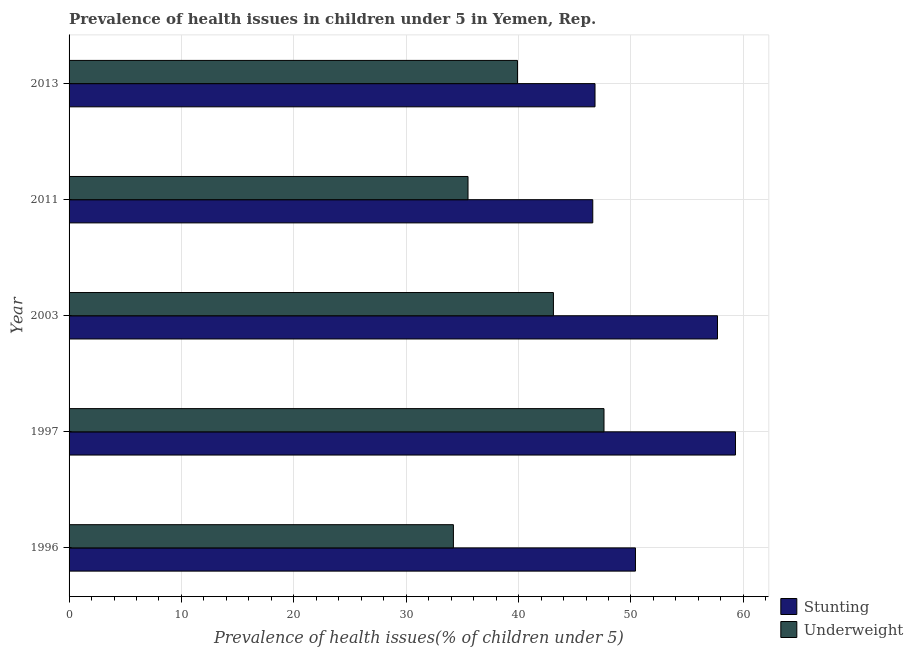How many different coloured bars are there?
Make the answer very short. 2. Are the number of bars per tick equal to the number of legend labels?
Your response must be concise. Yes. How many bars are there on the 3rd tick from the top?
Provide a succinct answer. 2. What is the label of the 2nd group of bars from the top?
Give a very brief answer. 2011. In how many cases, is the number of bars for a given year not equal to the number of legend labels?
Provide a succinct answer. 0. What is the percentage of stunted children in 2013?
Ensure brevity in your answer.  46.8. Across all years, what is the maximum percentage of stunted children?
Your response must be concise. 59.3. Across all years, what is the minimum percentage of stunted children?
Make the answer very short. 46.6. In which year was the percentage of underweight children maximum?
Provide a succinct answer. 1997. What is the total percentage of underweight children in the graph?
Offer a terse response. 200.3. What is the difference between the percentage of underweight children in 2003 and the percentage of stunted children in 1997?
Ensure brevity in your answer.  -16.2. What is the average percentage of underweight children per year?
Offer a terse response. 40.06. What is the ratio of the percentage of underweight children in 1996 to that in 2003?
Ensure brevity in your answer.  0.79. Is the percentage of underweight children in 2011 less than that in 2013?
Make the answer very short. Yes. Is the difference between the percentage of stunted children in 1997 and 2011 greater than the difference between the percentage of underweight children in 1997 and 2011?
Offer a very short reply. Yes. What is the difference between the highest and the second highest percentage of stunted children?
Your answer should be compact. 1.6. What does the 1st bar from the top in 2011 represents?
Offer a very short reply. Underweight. What does the 1st bar from the bottom in 1997 represents?
Provide a succinct answer. Stunting. Are all the bars in the graph horizontal?
Your answer should be compact. Yes. How many years are there in the graph?
Your answer should be very brief. 5. What is the difference between two consecutive major ticks on the X-axis?
Offer a terse response. 10. Does the graph contain grids?
Make the answer very short. Yes. Where does the legend appear in the graph?
Provide a short and direct response. Bottom right. How many legend labels are there?
Make the answer very short. 2. What is the title of the graph?
Your response must be concise. Prevalence of health issues in children under 5 in Yemen, Rep. What is the label or title of the X-axis?
Provide a succinct answer. Prevalence of health issues(% of children under 5). What is the Prevalence of health issues(% of children under 5) of Stunting in 1996?
Ensure brevity in your answer.  50.4. What is the Prevalence of health issues(% of children under 5) in Underweight in 1996?
Ensure brevity in your answer.  34.2. What is the Prevalence of health issues(% of children under 5) of Stunting in 1997?
Offer a very short reply. 59.3. What is the Prevalence of health issues(% of children under 5) in Underweight in 1997?
Ensure brevity in your answer.  47.6. What is the Prevalence of health issues(% of children under 5) of Stunting in 2003?
Make the answer very short. 57.7. What is the Prevalence of health issues(% of children under 5) in Underweight in 2003?
Your answer should be compact. 43.1. What is the Prevalence of health issues(% of children under 5) in Stunting in 2011?
Ensure brevity in your answer.  46.6. What is the Prevalence of health issues(% of children under 5) of Underweight in 2011?
Provide a succinct answer. 35.5. What is the Prevalence of health issues(% of children under 5) of Stunting in 2013?
Provide a succinct answer. 46.8. What is the Prevalence of health issues(% of children under 5) in Underweight in 2013?
Provide a succinct answer. 39.9. Across all years, what is the maximum Prevalence of health issues(% of children under 5) of Stunting?
Keep it short and to the point. 59.3. Across all years, what is the maximum Prevalence of health issues(% of children under 5) in Underweight?
Your answer should be very brief. 47.6. Across all years, what is the minimum Prevalence of health issues(% of children under 5) of Stunting?
Your answer should be very brief. 46.6. Across all years, what is the minimum Prevalence of health issues(% of children under 5) of Underweight?
Provide a succinct answer. 34.2. What is the total Prevalence of health issues(% of children under 5) in Stunting in the graph?
Make the answer very short. 260.8. What is the total Prevalence of health issues(% of children under 5) in Underweight in the graph?
Provide a succinct answer. 200.3. What is the difference between the Prevalence of health issues(% of children under 5) in Underweight in 1996 and that in 1997?
Make the answer very short. -13.4. What is the difference between the Prevalence of health issues(% of children under 5) in Stunting in 1996 and that in 2003?
Ensure brevity in your answer.  -7.3. What is the difference between the Prevalence of health issues(% of children under 5) of Stunting in 1996 and that in 2011?
Your answer should be very brief. 3.8. What is the difference between the Prevalence of health issues(% of children under 5) in Underweight in 1996 and that in 2011?
Your answer should be compact. -1.3. What is the difference between the Prevalence of health issues(% of children under 5) in Stunting in 1997 and that in 2013?
Provide a short and direct response. 12.5. What is the difference between the Prevalence of health issues(% of children under 5) of Underweight in 2003 and that in 2011?
Provide a short and direct response. 7.6. What is the difference between the Prevalence of health issues(% of children under 5) in Stunting in 2003 and that in 2013?
Make the answer very short. 10.9. What is the difference between the Prevalence of health issues(% of children under 5) of Underweight in 2011 and that in 2013?
Your response must be concise. -4.4. What is the difference between the Prevalence of health issues(% of children under 5) in Stunting in 1996 and the Prevalence of health issues(% of children under 5) in Underweight in 1997?
Make the answer very short. 2.8. What is the difference between the Prevalence of health issues(% of children under 5) of Stunting in 1996 and the Prevalence of health issues(% of children under 5) of Underweight in 2003?
Provide a succinct answer. 7.3. What is the difference between the Prevalence of health issues(% of children under 5) of Stunting in 1997 and the Prevalence of health issues(% of children under 5) of Underweight in 2003?
Provide a short and direct response. 16.2. What is the difference between the Prevalence of health issues(% of children under 5) in Stunting in 1997 and the Prevalence of health issues(% of children under 5) in Underweight in 2011?
Your answer should be compact. 23.8. What is the difference between the Prevalence of health issues(% of children under 5) of Stunting in 2011 and the Prevalence of health issues(% of children under 5) of Underweight in 2013?
Give a very brief answer. 6.7. What is the average Prevalence of health issues(% of children under 5) of Stunting per year?
Keep it short and to the point. 52.16. What is the average Prevalence of health issues(% of children under 5) in Underweight per year?
Give a very brief answer. 40.06. In the year 1996, what is the difference between the Prevalence of health issues(% of children under 5) of Stunting and Prevalence of health issues(% of children under 5) of Underweight?
Ensure brevity in your answer.  16.2. In the year 1997, what is the difference between the Prevalence of health issues(% of children under 5) of Stunting and Prevalence of health issues(% of children under 5) of Underweight?
Your answer should be compact. 11.7. In the year 2003, what is the difference between the Prevalence of health issues(% of children under 5) in Stunting and Prevalence of health issues(% of children under 5) in Underweight?
Offer a terse response. 14.6. In the year 2011, what is the difference between the Prevalence of health issues(% of children under 5) in Stunting and Prevalence of health issues(% of children under 5) in Underweight?
Keep it short and to the point. 11.1. In the year 2013, what is the difference between the Prevalence of health issues(% of children under 5) of Stunting and Prevalence of health issues(% of children under 5) of Underweight?
Your answer should be very brief. 6.9. What is the ratio of the Prevalence of health issues(% of children under 5) in Stunting in 1996 to that in 1997?
Your answer should be very brief. 0.85. What is the ratio of the Prevalence of health issues(% of children under 5) in Underweight in 1996 to that in 1997?
Make the answer very short. 0.72. What is the ratio of the Prevalence of health issues(% of children under 5) of Stunting in 1996 to that in 2003?
Your answer should be compact. 0.87. What is the ratio of the Prevalence of health issues(% of children under 5) of Underweight in 1996 to that in 2003?
Your answer should be very brief. 0.79. What is the ratio of the Prevalence of health issues(% of children under 5) of Stunting in 1996 to that in 2011?
Ensure brevity in your answer.  1.08. What is the ratio of the Prevalence of health issues(% of children under 5) in Underweight in 1996 to that in 2011?
Ensure brevity in your answer.  0.96. What is the ratio of the Prevalence of health issues(% of children under 5) of Stunting in 1997 to that in 2003?
Provide a succinct answer. 1.03. What is the ratio of the Prevalence of health issues(% of children under 5) of Underweight in 1997 to that in 2003?
Keep it short and to the point. 1.1. What is the ratio of the Prevalence of health issues(% of children under 5) in Stunting in 1997 to that in 2011?
Offer a terse response. 1.27. What is the ratio of the Prevalence of health issues(% of children under 5) of Underweight in 1997 to that in 2011?
Provide a succinct answer. 1.34. What is the ratio of the Prevalence of health issues(% of children under 5) in Stunting in 1997 to that in 2013?
Offer a very short reply. 1.27. What is the ratio of the Prevalence of health issues(% of children under 5) in Underweight in 1997 to that in 2013?
Keep it short and to the point. 1.19. What is the ratio of the Prevalence of health issues(% of children under 5) in Stunting in 2003 to that in 2011?
Provide a short and direct response. 1.24. What is the ratio of the Prevalence of health issues(% of children under 5) of Underweight in 2003 to that in 2011?
Ensure brevity in your answer.  1.21. What is the ratio of the Prevalence of health issues(% of children under 5) of Stunting in 2003 to that in 2013?
Make the answer very short. 1.23. What is the ratio of the Prevalence of health issues(% of children under 5) in Underweight in 2003 to that in 2013?
Your response must be concise. 1.08. What is the ratio of the Prevalence of health issues(% of children under 5) of Underweight in 2011 to that in 2013?
Your answer should be compact. 0.89. What is the difference between the highest and the second highest Prevalence of health issues(% of children under 5) in Stunting?
Your answer should be very brief. 1.6. What is the difference between the highest and the lowest Prevalence of health issues(% of children under 5) in Stunting?
Your answer should be very brief. 12.7. 